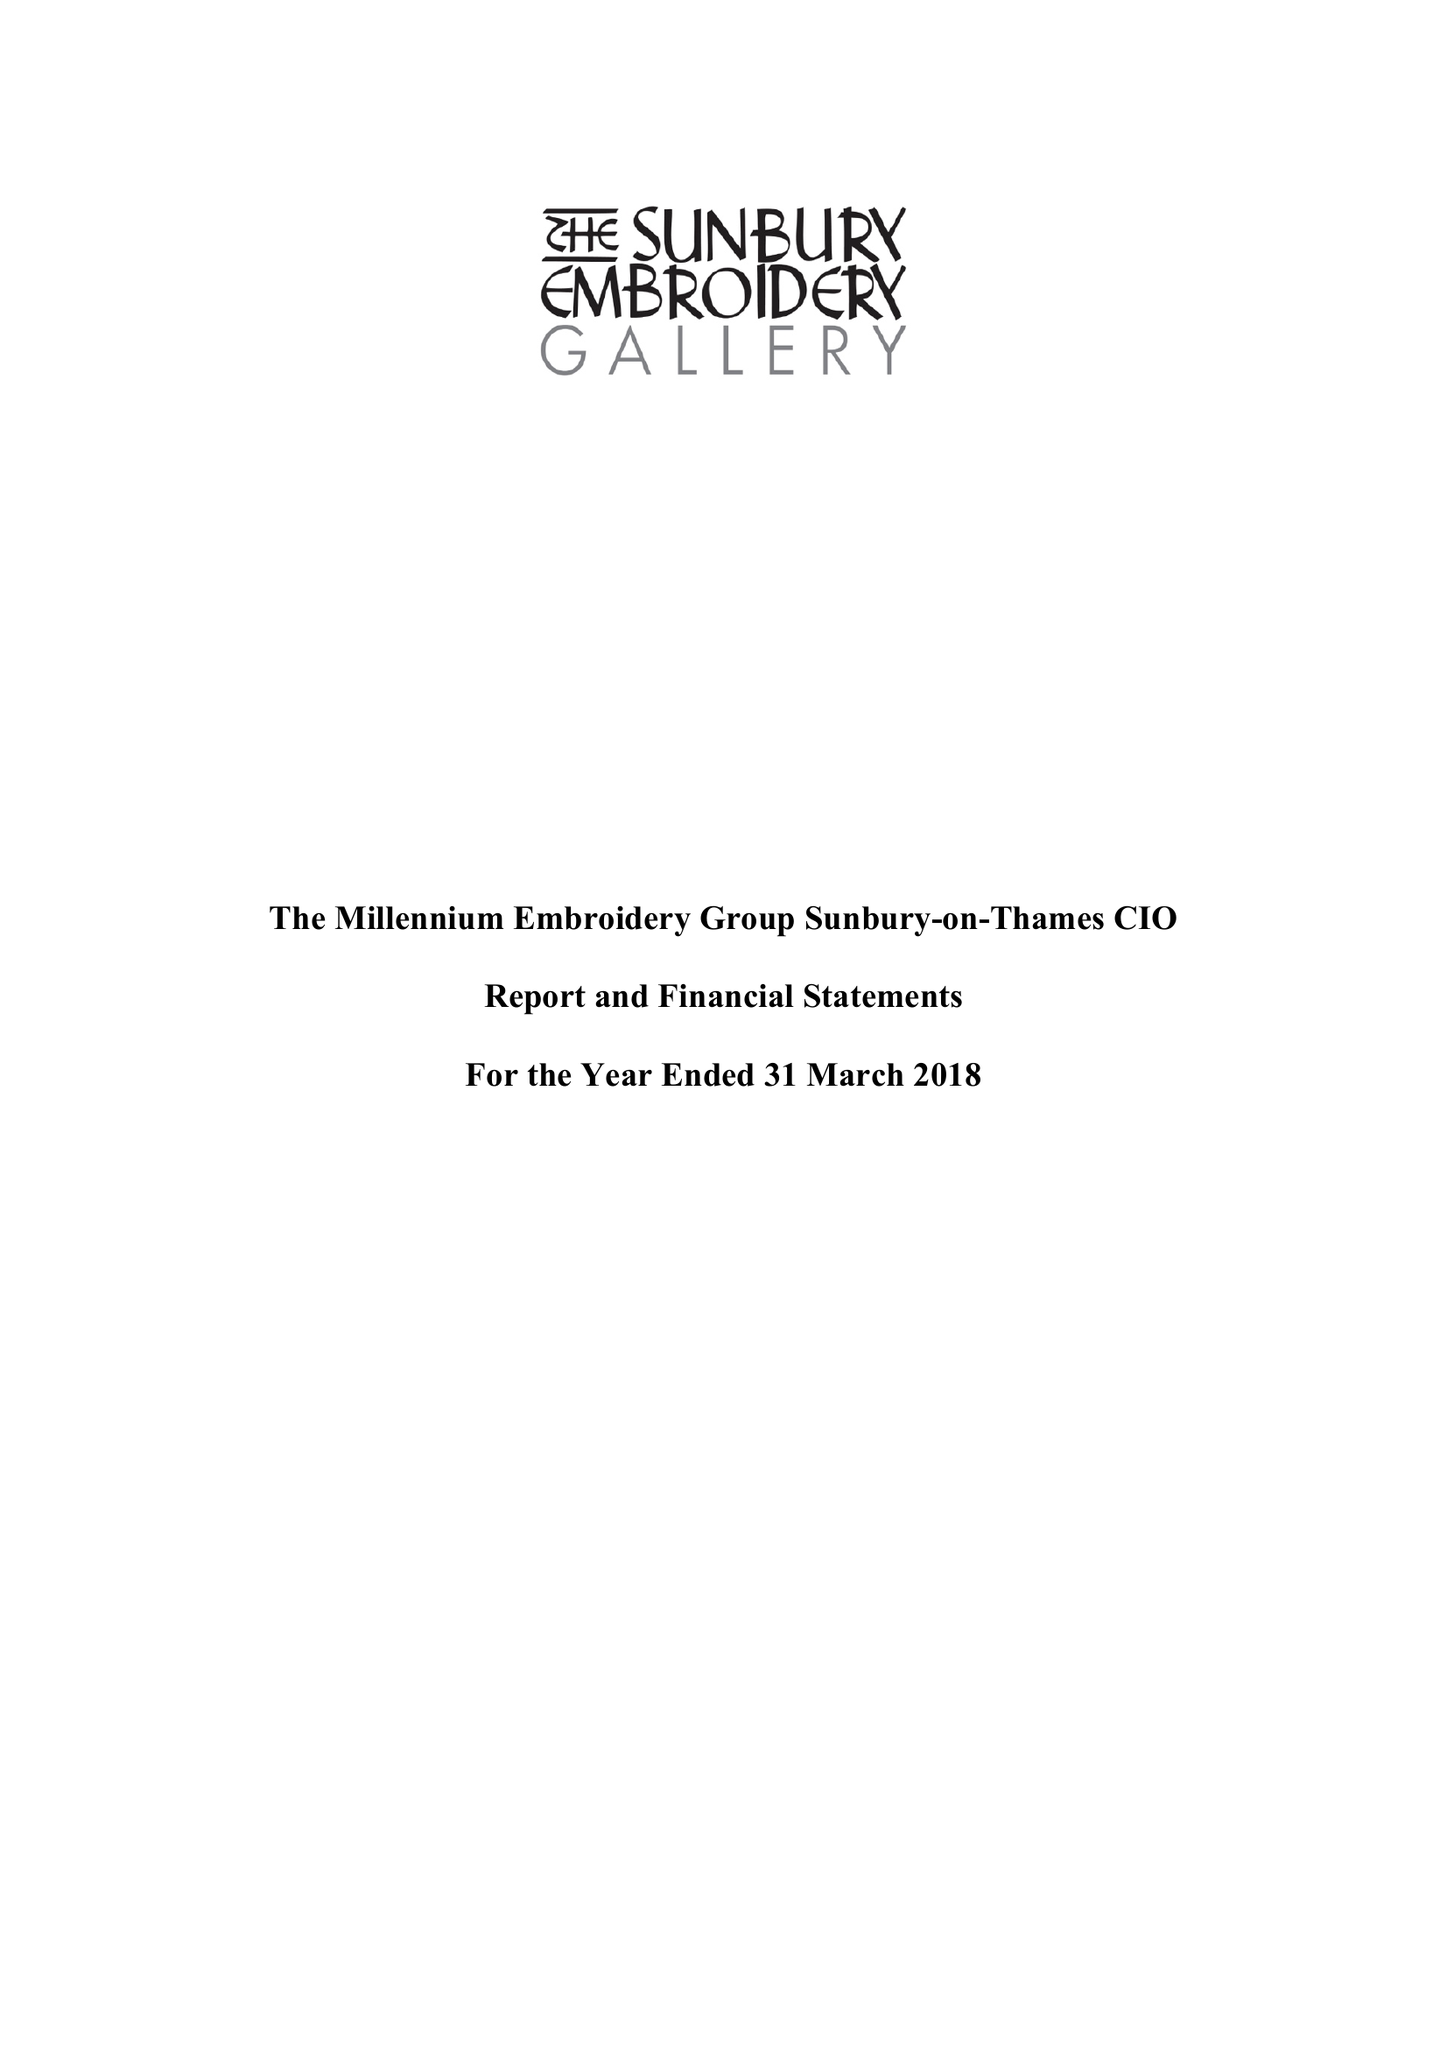What is the value for the income_annually_in_british_pounds?
Answer the question using a single word or phrase. 174975.00 